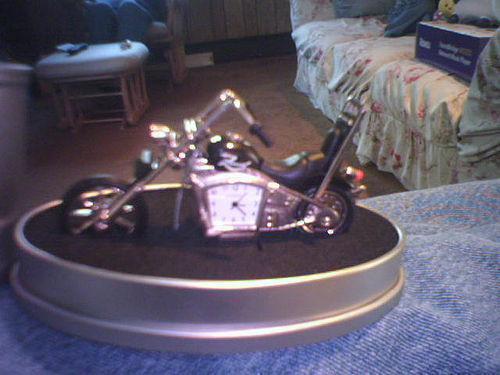What best describes the size of the motorcycle?
Select the accurate response from the four choices given to answer the question.
Options: 12 feet, 10 feet, miniature, 30 inches. Miniature. 